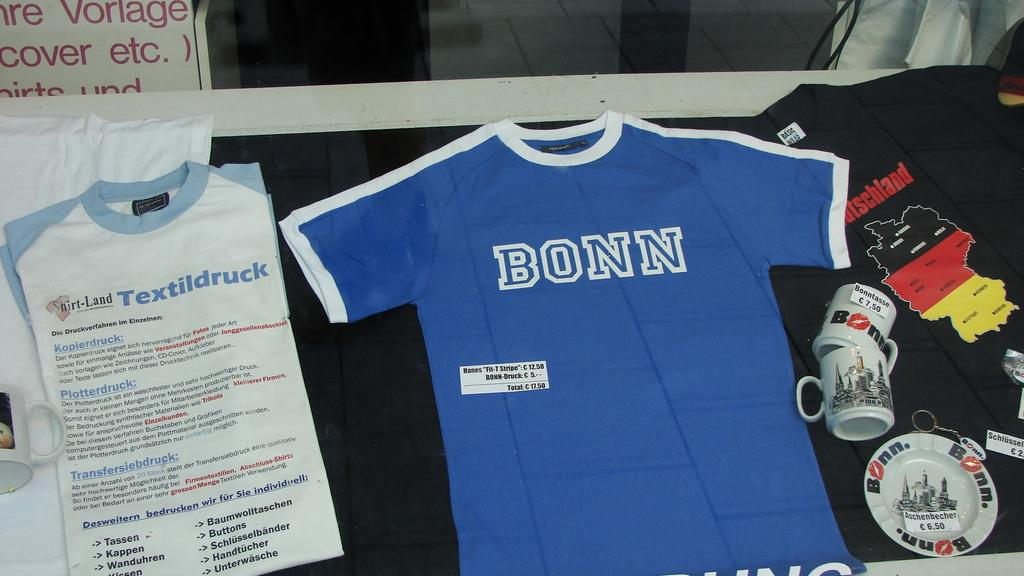<image>
Write a terse but informative summary of the picture. A Bonn t-shirt is displayed on the table. 